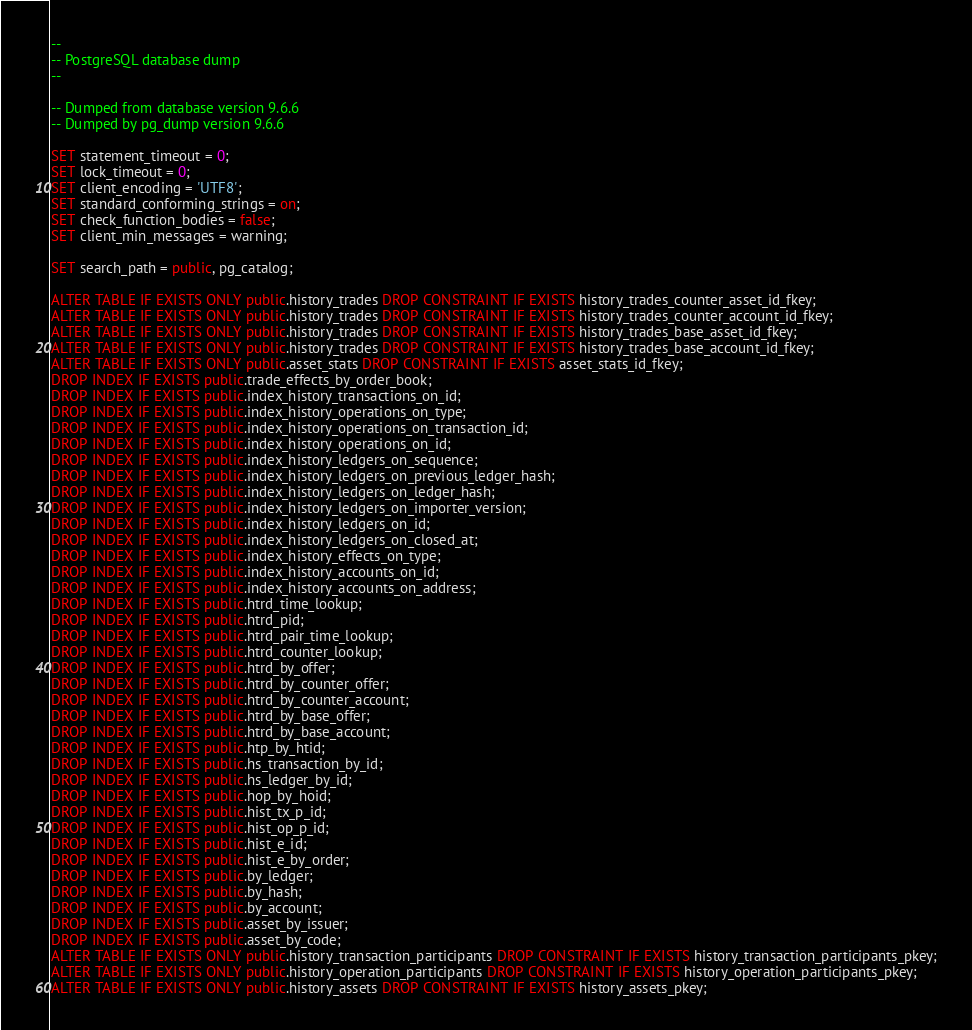<code> <loc_0><loc_0><loc_500><loc_500><_SQL_>--
-- PostgreSQL database dump
--

-- Dumped from database version 9.6.6
-- Dumped by pg_dump version 9.6.6

SET statement_timeout = 0;
SET lock_timeout = 0;
SET client_encoding = 'UTF8';
SET standard_conforming_strings = on;
SET check_function_bodies = false;
SET client_min_messages = warning;

SET search_path = public, pg_catalog;

ALTER TABLE IF EXISTS ONLY public.history_trades DROP CONSTRAINT IF EXISTS history_trades_counter_asset_id_fkey;
ALTER TABLE IF EXISTS ONLY public.history_trades DROP CONSTRAINT IF EXISTS history_trades_counter_account_id_fkey;
ALTER TABLE IF EXISTS ONLY public.history_trades DROP CONSTRAINT IF EXISTS history_trades_base_asset_id_fkey;
ALTER TABLE IF EXISTS ONLY public.history_trades DROP CONSTRAINT IF EXISTS history_trades_base_account_id_fkey;
ALTER TABLE IF EXISTS ONLY public.asset_stats DROP CONSTRAINT IF EXISTS asset_stats_id_fkey;
DROP INDEX IF EXISTS public.trade_effects_by_order_book;
DROP INDEX IF EXISTS public.index_history_transactions_on_id;
DROP INDEX IF EXISTS public.index_history_operations_on_type;
DROP INDEX IF EXISTS public.index_history_operations_on_transaction_id;
DROP INDEX IF EXISTS public.index_history_operations_on_id;
DROP INDEX IF EXISTS public.index_history_ledgers_on_sequence;
DROP INDEX IF EXISTS public.index_history_ledgers_on_previous_ledger_hash;
DROP INDEX IF EXISTS public.index_history_ledgers_on_ledger_hash;
DROP INDEX IF EXISTS public.index_history_ledgers_on_importer_version;
DROP INDEX IF EXISTS public.index_history_ledgers_on_id;
DROP INDEX IF EXISTS public.index_history_ledgers_on_closed_at;
DROP INDEX IF EXISTS public.index_history_effects_on_type;
DROP INDEX IF EXISTS public.index_history_accounts_on_id;
DROP INDEX IF EXISTS public.index_history_accounts_on_address;
DROP INDEX IF EXISTS public.htrd_time_lookup;
DROP INDEX IF EXISTS public.htrd_pid;
DROP INDEX IF EXISTS public.htrd_pair_time_lookup;
DROP INDEX IF EXISTS public.htrd_counter_lookup;
DROP INDEX IF EXISTS public.htrd_by_offer;
DROP INDEX IF EXISTS public.htrd_by_counter_offer;
DROP INDEX IF EXISTS public.htrd_by_counter_account;
DROP INDEX IF EXISTS public.htrd_by_base_offer;
DROP INDEX IF EXISTS public.htrd_by_base_account;
DROP INDEX IF EXISTS public.htp_by_htid;
DROP INDEX IF EXISTS public.hs_transaction_by_id;
DROP INDEX IF EXISTS public.hs_ledger_by_id;
DROP INDEX IF EXISTS public.hop_by_hoid;
DROP INDEX IF EXISTS public.hist_tx_p_id;
DROP INDEX IF EXISTS public.hist_op_p_id;
DROP INDEX IF EXISTS public.hist_e_id;
DROP INDEX IF EXISTS public.hist_e_by_order;
DROP INDEX IF EXISTS public.by_ledger;
DROP INDEX IF EXISTS public.by_hash;
DROP INDEX IF EXISTS public.by_account;
DROP INDEX IF EXISTS public.asset_by_issuer;
DROP INDEX IF EXISTS public.asset_by_code;
ALTER TABLE IF EXISTS ONLY public.history_transaction_participants DROP CONSTRAINT IF EXISTS history_transaction_participants_pkey;
ALTER TABLE IF EXISTS ONLY public.history_operation_participants DROP CONSTRAINT IF EXISTS history_operation_participants_pkey;
ALTER TABLE IF EXISTS ONLY public.history_assets DROP CONSTRAINT IF EXISTS history_assets_pkey;</code> 